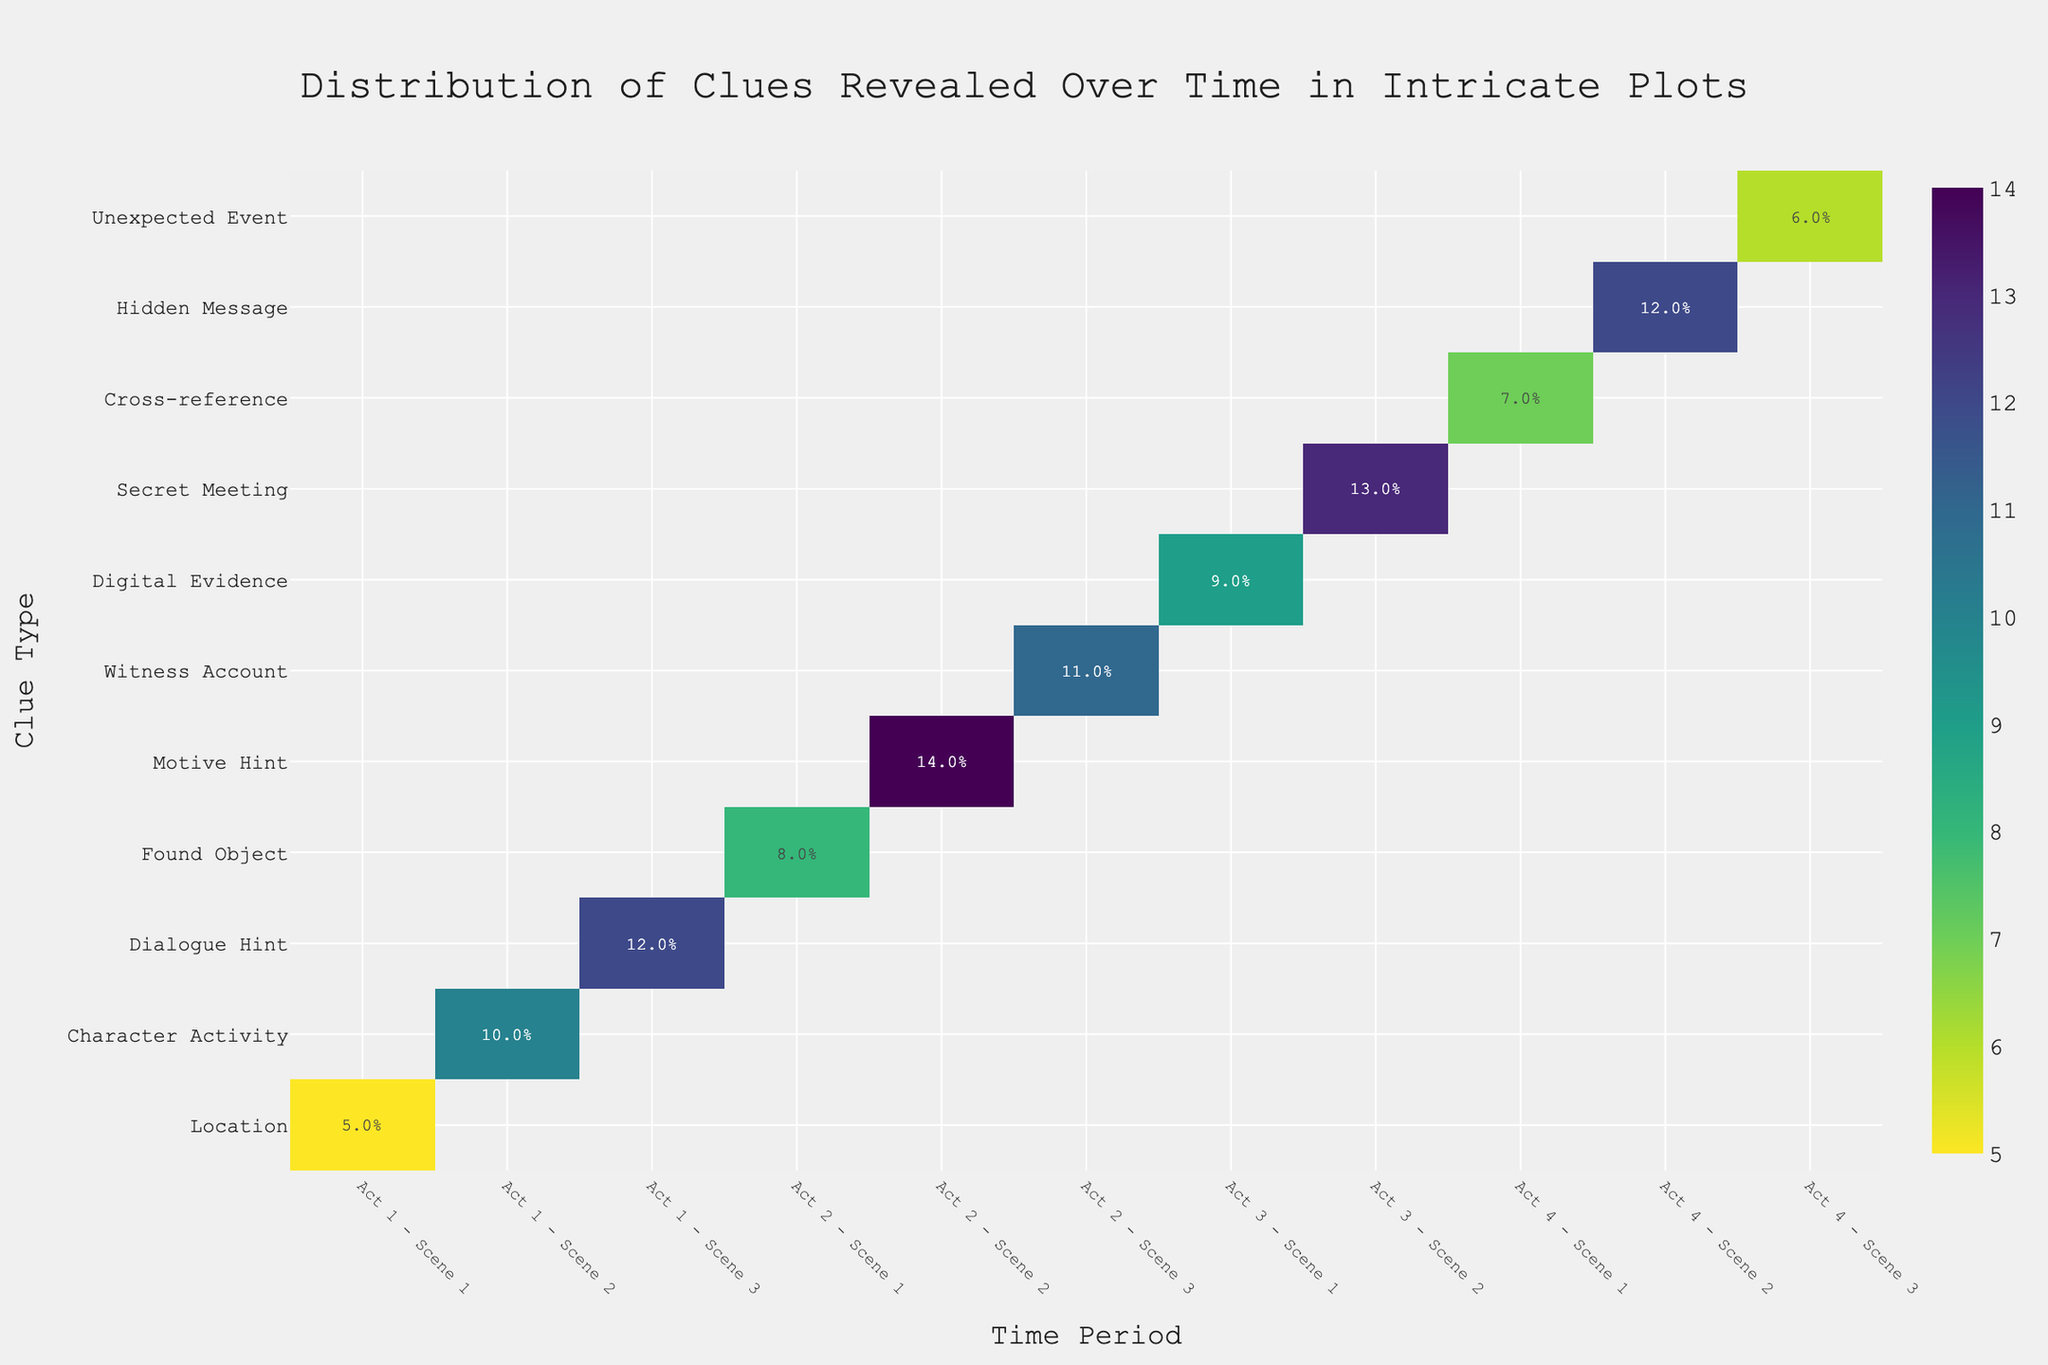What's the title of the figure? The title is placed at the top center of the figure in a distinct color and larger font size. It reads: "Distribution of Clues Revealed Over Time in Intricate Plots".
Answer: Distribution of Clues Revealed Over Time in Intricate Plots Which clue type in Act 1 is revealed the most? To determine which clue type in Act 1 is revealed the most, look at all the clue types for scenes in Act 1 and compare their revealed percentages. The Dialogue Hint in Act 1 - Scene 3 has the highest revealed percentage at 12%.
Answer: Dialogue Hint Between Act 2 - Scene 2 and Act 3 - Scene 2, which scene has more clues revealed? Compare the revealed percentages for Act 2 - Scene 2 (Motive Hint) and Act 3 - Scene 2 (Secret Meeting). Act 2 - Scene 2 has 14% revealed, whereas Act 3 - Scene 2 has 13% revealed. Thus, Act 2 - Scene 2 has more clues revealed.
Answer: Act 2 - Scene 2 What is the least revealed clue type in Act 4? For Act 4, compare the revealed percentages of all clue types listed (Cross-reference, Hidden Message, Unexpected Event). The clue type with the lowest revealed percentage is the Unexpected Event at 6%.
Answer: Unexpected Event Calculate the average percentage of clues revealed across all clue types in Act 3. Identify the revealed percentages for all clue types in Act 3: Digital Evidence (9%), Secret Meeting (13%). Average these values: (9 + 13) / 2 = 11%.
Answer: 11% How many time periods have a revealed percentage above 10%? Check each time period for the revealed percentage and count the ones above 10%. They are Act 1 - Scene 2, Act 1 - Scene 3, Act 2 - Scene 2, Act 3 - Scene 2, and Act 4 - Scene 2, totaling 5 time periods.
Answer: 5 In which scene does the clue type 'Character Activity' appear and what percentage of clues is revealed there? Look for the Character Activity clue type and note its scene and revealed percentage. It appears in Act 1 - Scene 2 with 10% revealed.
Answer: Act 1 - Scene 2, 10% Which act has the highest average percentage of clues revealed? Calculate the average revealed percentage for each act, then compare the averages. Act 1: (5 + 10 + 12)/3 = 9%; Act 2: (8 + 14 + 11)/3 = 11%; Act 3: (9 + 13)/2 = 11%; Act 4: (7 + 12 + 6)/3 ≈ 8.33%. Act 2 and Act 3 both have the highest average at 11%.
Answer: Act 2 & Act 3 (tie) Which clue type has been revealed the most overall throughout the plot? Compare the revealed percentages for each clue type regardless of act. The Motive Hint in Act 2 - Scene 2 has the highest percentage at 14%.
Answer: Motive Hint 